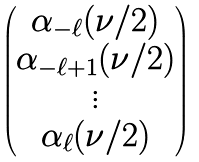<formula> <loc_0><loc_0><loc_500><loc_500>\begin{pmatrix} \alpha _ { - \ell } ( \nu / 2 ) \\ \alpha _ { - \ell + 1 } ( \nu / 2 ) \\ \vdots \\ \alpha _ { \ell } ( \nu / 2 ) \end{pmatrix}</formula> 